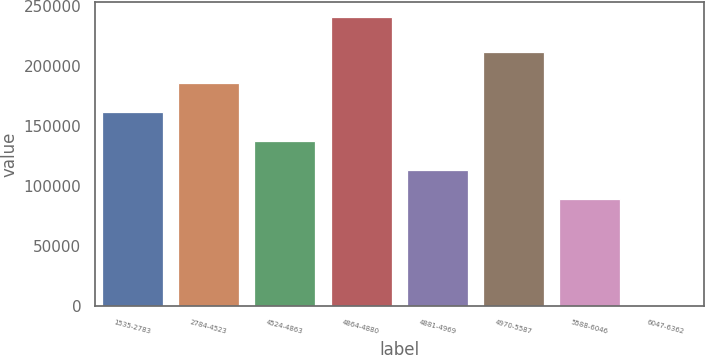Convert chart. <chart><loc_0><loc_0><loc_500><loc_500><bar_chart><fcel>1535-2783<fcel>2784-4523<fcel>4524-4863<fcel>4864-4880<fcel>4881-4969<fcel>4970-5587<fcel>5588-6046<fcel>6047-6362<nl><fcel>161675<fcel>185760<fcel>137590<fcel>241392<fcel>113504<fcel>212176<fcel>89419<fcel>539<nl></chart> 